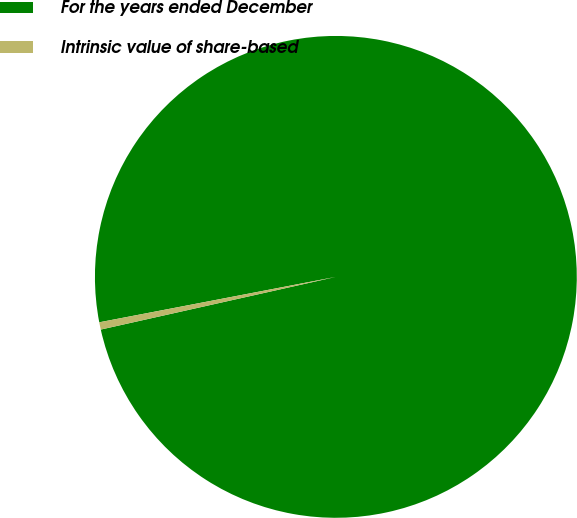<chart> <loc_0><loc_0><loc_500><loc_500><pie_chart><fcel>For the years ended December<fcel>Intrinsic value of share-based<nl><fcel>99.51%<fcel>0.49%<nl></chart> 